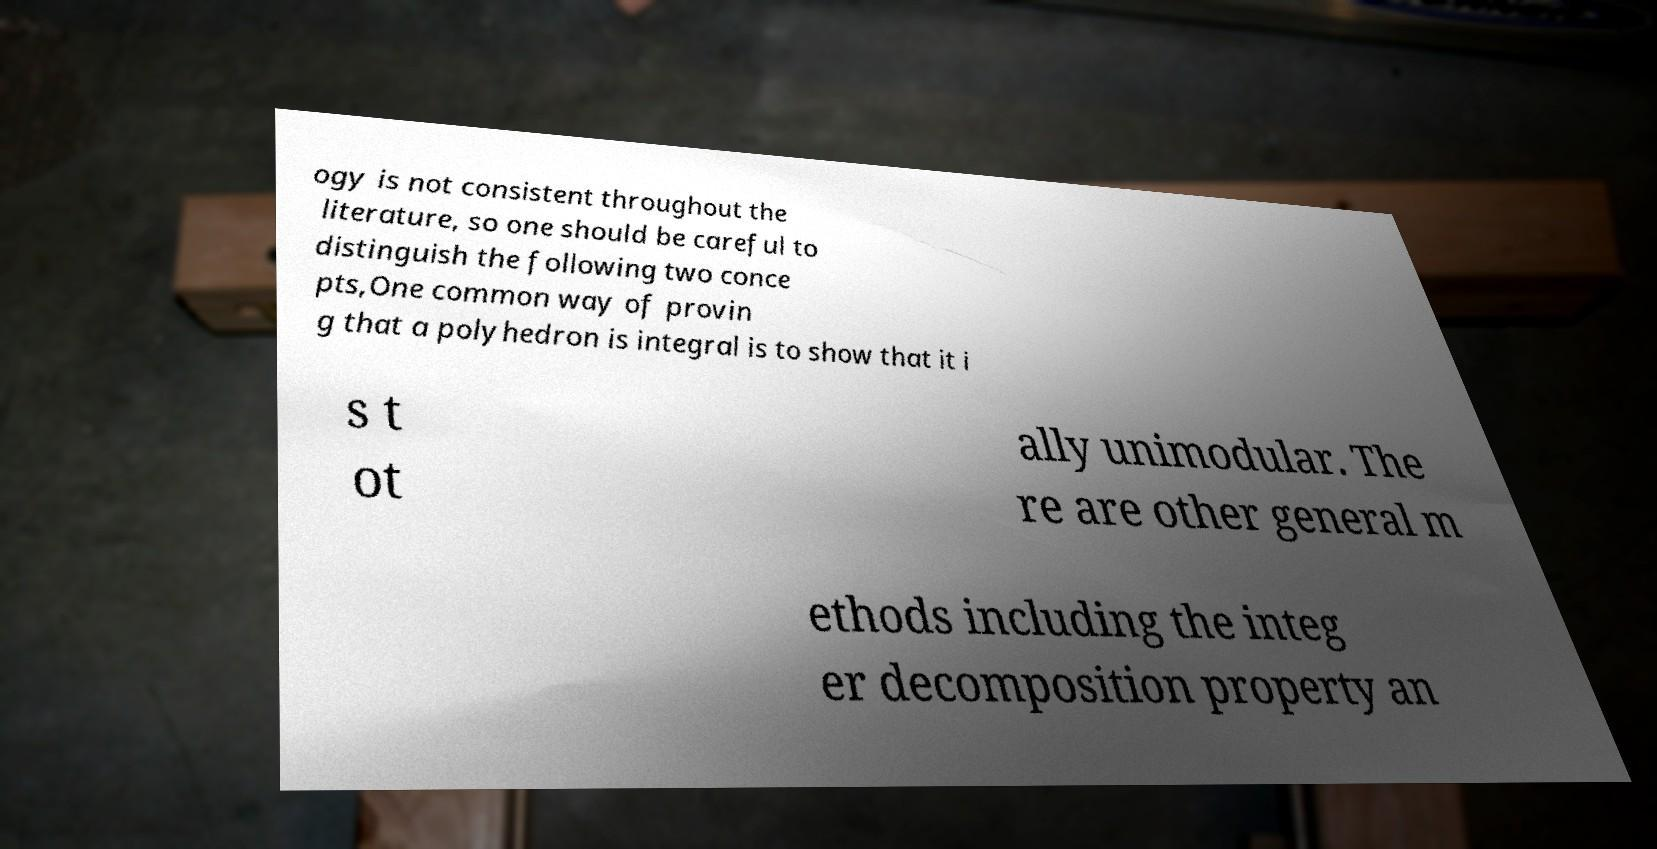There's text embedded in this image that I need extracted. Can you transcribe it verbatim? ogy is not consistent throughout the literature, so one should be careful to distinguish the following two conce pts,One common way of provin g that a polyhedron is integral is to show that it i s t ot ally unimodular. The re are other general m ethods including the integ er decomposition property an 